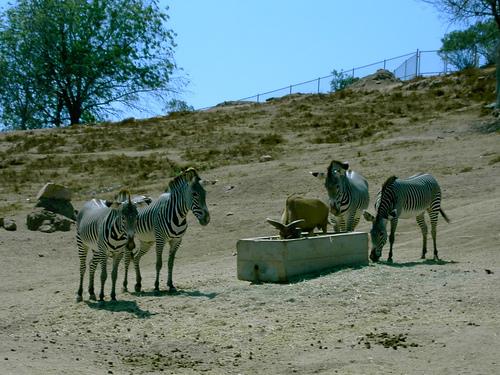Is there grass on the ground?
Answer briefly. No. Are the animals undernourished?
Be succinct. No. Why is there a wall between the zebras?
Be succinct. No. Is this a grassy area?
Short answer required. No. How many types of animals are walking in the road?
Be succinct. 2. Is the area woody?
Keep it brief. No. How is the weather?
Quick response, please. Sunny. Are the two zebras staring at each other?
Short answer required. No. How many zebras?
Concise answer only. 4. How colorful is this image?
Concise answer only. Not very. Are the animals gay?
Short answer required. No. What trees are in the back?
Write a very short answer. Oak. How many animals are eating?
Write a very short answer. 1. What liquid does this animal produce for humans?
Give a very brief answer. Milk. Is this animal drinking?
Give a very brief answer. Yes. How many zebras are depicted?
Short answer required. 4. Which Zebra is lying down?
Concise answer only. 0. 